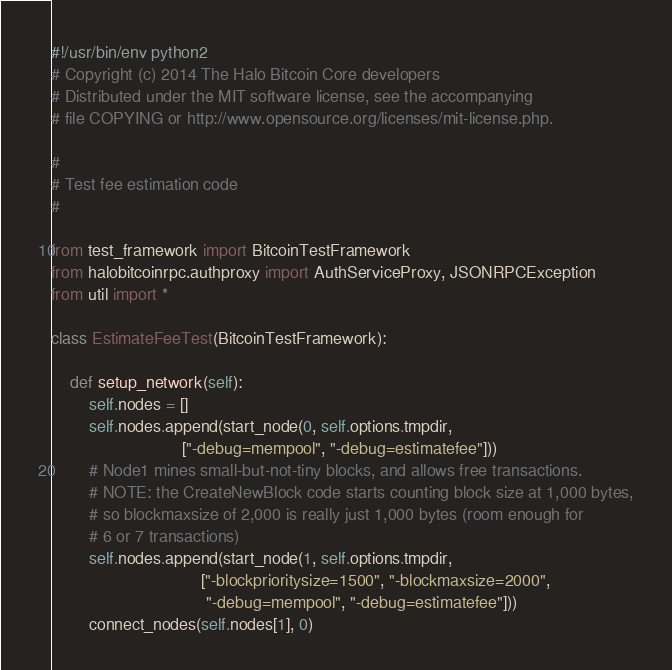Convert code to text. <code><loc_0><loc_0><loc_500><loc_500><_Python_>#!/usr/bin/env python2
# Copyright (c) 2014 The Halo Bitcoin Core developers
# Distributed under the MIT software license, see the accompanying
# file COPYING or http://www.opensource.org/licenses/mit-license.php.

#
# Test fee estimation code
#

from test_framework import BitcoinTestFramework
from halobitcoinrpc.authproxy import AuthServiceProxy, JSONRPCException
from util import *

class EstimateFeeTest(BitcoinTestFramework):

    def setup_network(self):
        self.nodes = []
        self.nodes.append(start_node(0, self.options.tmpdir,
                            ["-debug=mempool", "-debug=estimatefee"]))
        # Node1 mines small-but-not-tiny blocks, and allows free transactions.
        # NOTE: the CreateNewBlock code starts counting block size at 1,000 bytes,
        # so blockmaxsize of 2,000 is really just 1,000 bytes (room enough for
        # 6 or 7 transactions)
        self.nodes.append(start_node(1, self.options.tmpdir,
                                ["-blockprioritysize=1500", "-blockmaxsize=2000",
                                 "-debug=mempool", "-debug=estimatefee"]))
        connect_nodes(self.nodes[1], 0)
</code> 